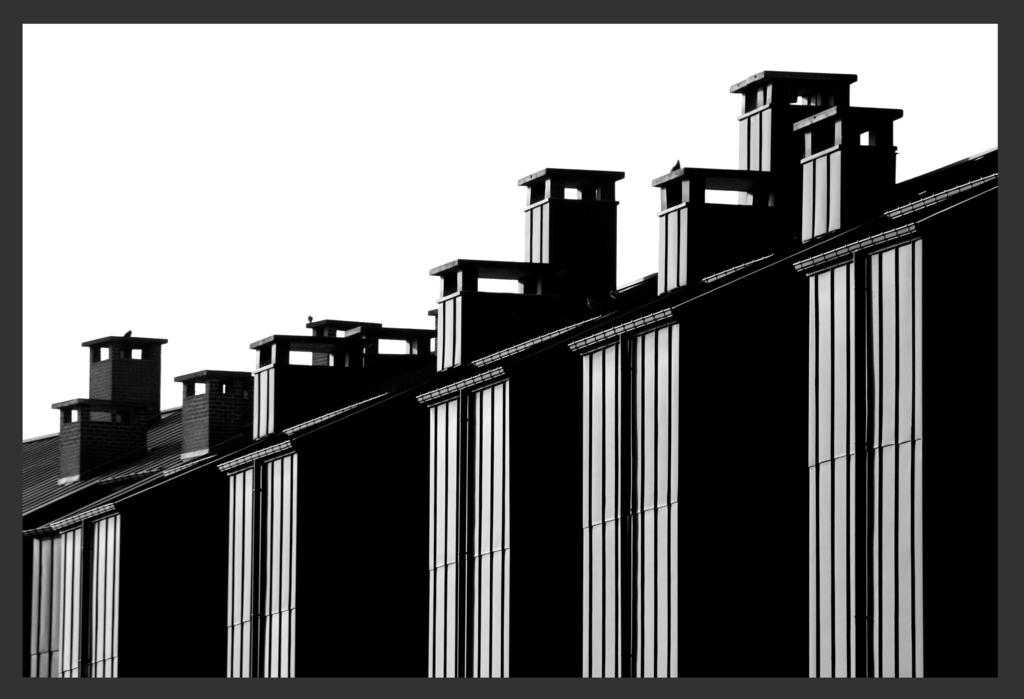What type of image is being described? The image is animated. What can be seen in the animated image? There are buildings in the image. What type of skin condition is visible on the buildings in the image? There is no skin condition present in the image, as the buildings are not living organisms and cannot have skin conditions. 